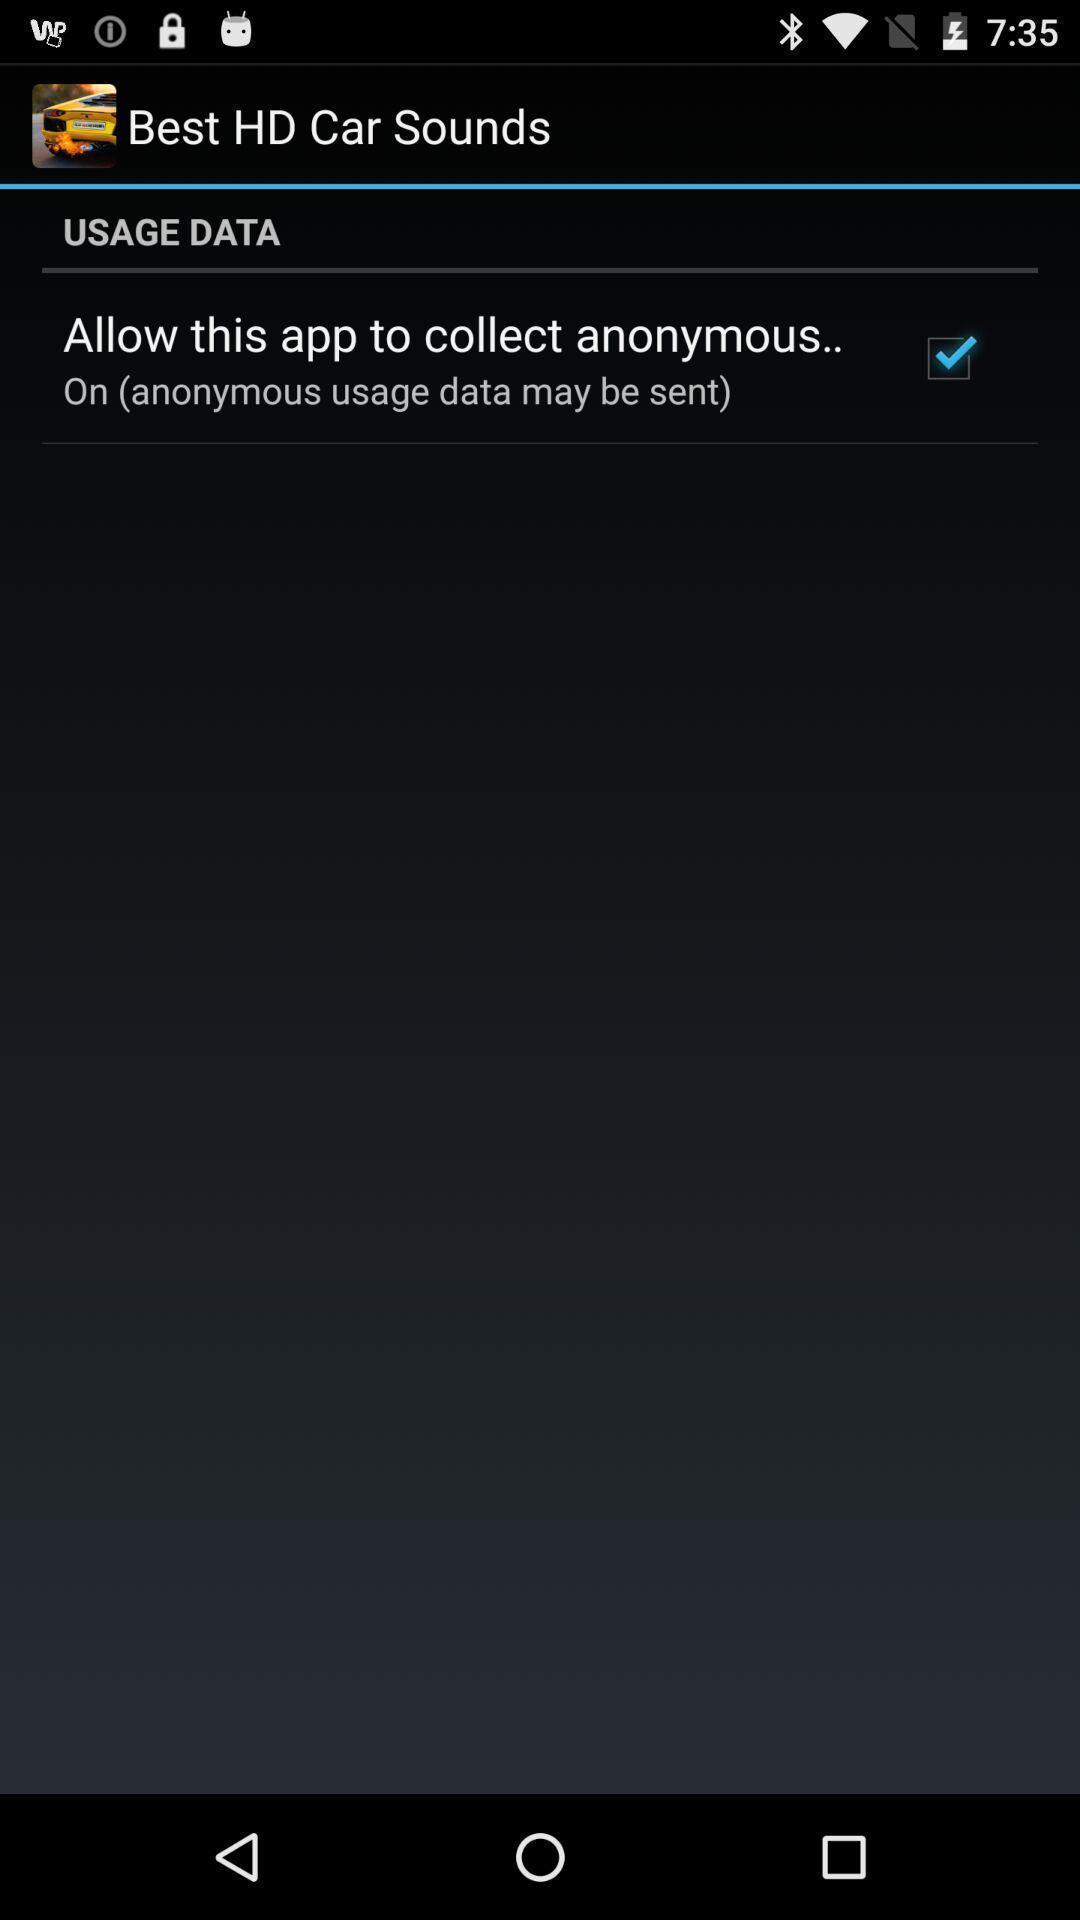What is the overall content of this screenshot? Screen displaying a checked option in a mobile application. 